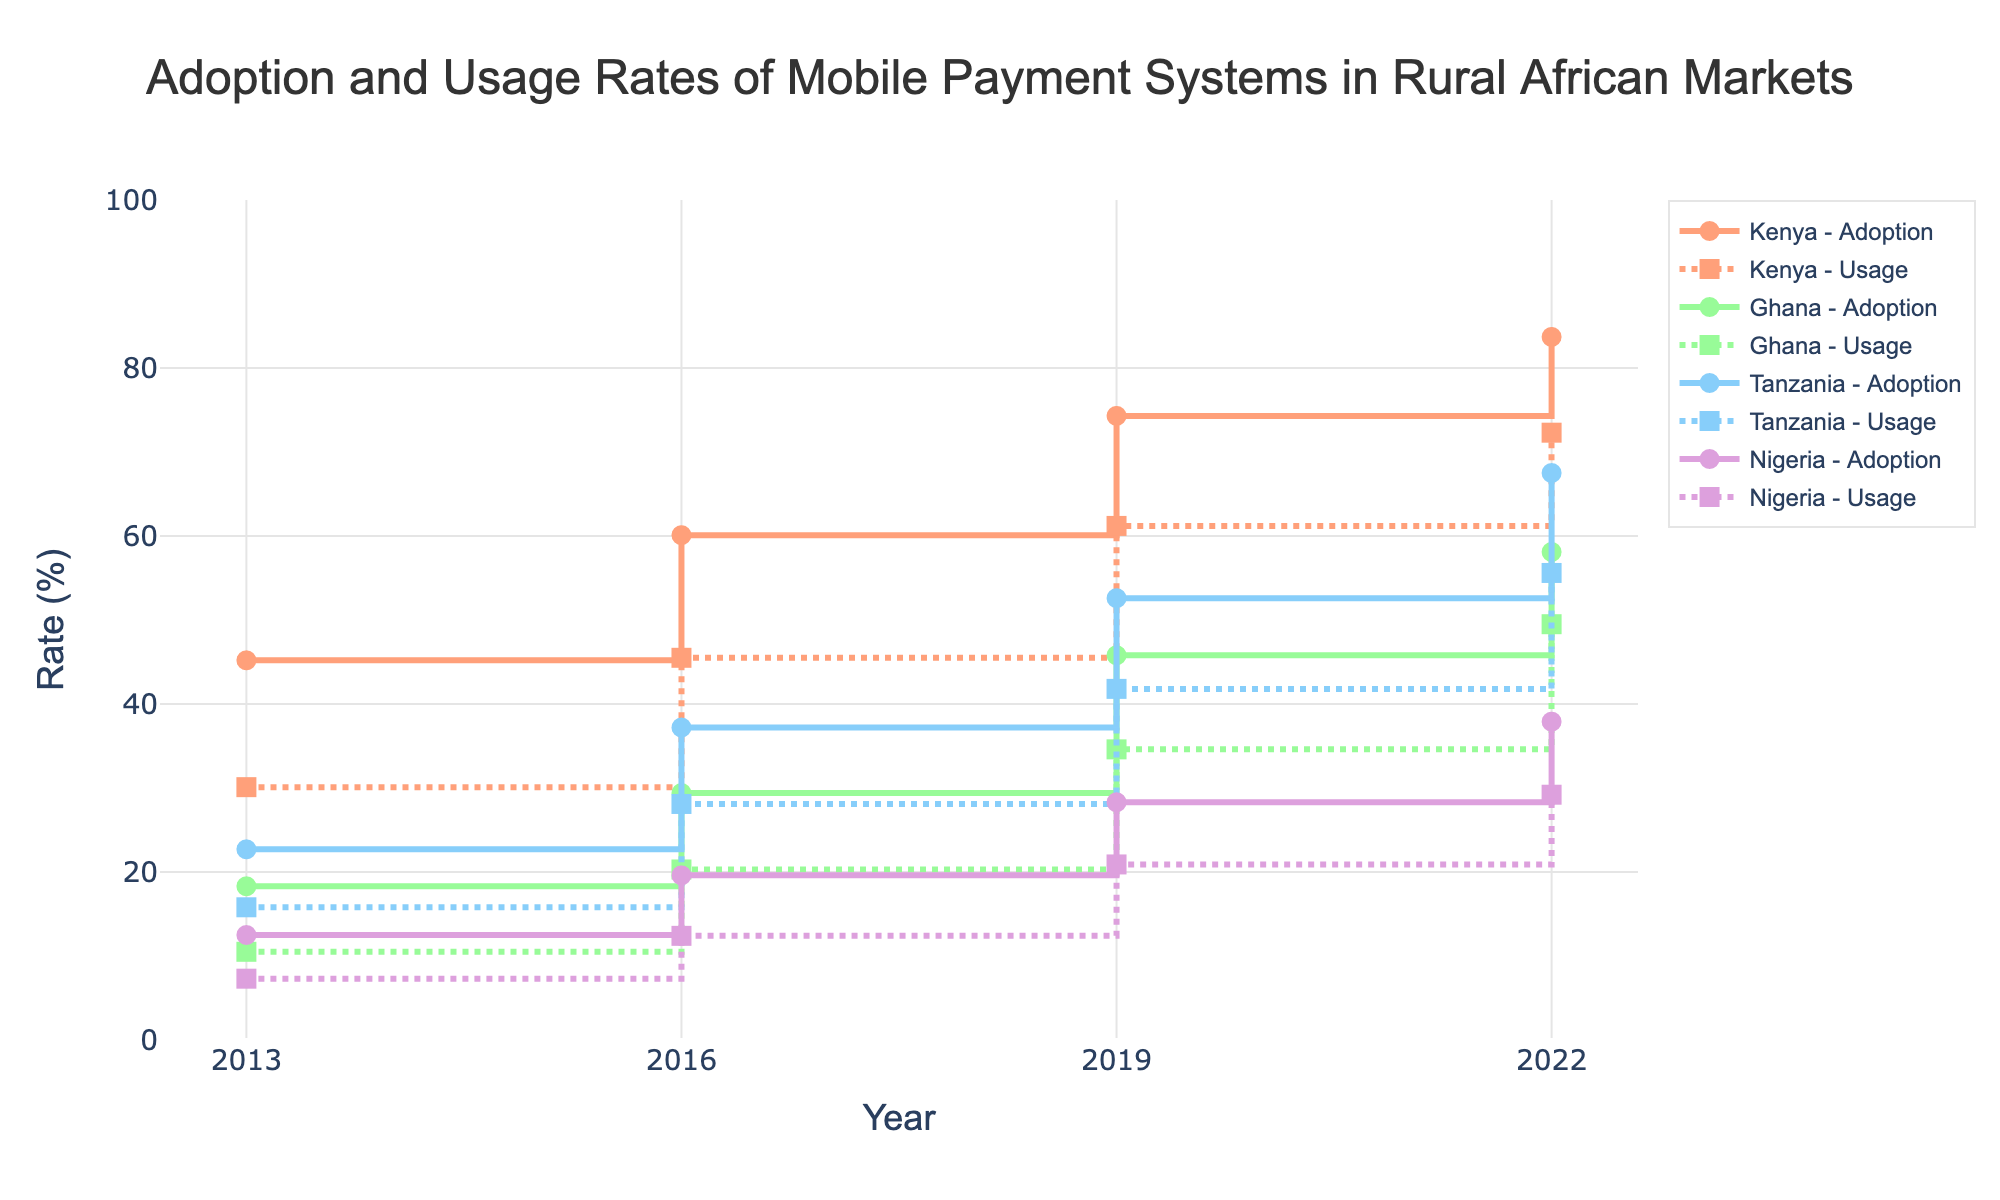what is the title of the figure? The title is always located at the top center of the figure and is usually the most prominent text. In this figure, it clearly states the content being visualized.
Answer: Adoption and Usage Rates of Mobile Payment Systems in Rural African Markets What years are covered in the figure? By examining the x-axis, which represents the years, we can see the tick marks indicating each year that data was collected.
Answer: 2013, 2016, 2019, 2022 Which country shows the highest adoption rate in 2022? By looking at the markers for the adoption rate in the year 2022 and identifying the highest point among them, we see that Kenya has the highest adoption rate.
Answer: Kenya How does the usage rate in Ghana in 2016 compare to the usage rate in Tanzania in the same year? To answer this, we locate the usage rate markers for both Ghana and Tanzania in 2016 and compare their values. Ghana's rate is 20.3%, while Tanzania's rate is 28.1%, making Tanzania's usage rate higher.
Answer: Tanzania's rate is higher What is the average adoption rate for Nigeria over the years presented in the figure? First, list Nigeria's adoption rates for all the years (12.5%, 19.6%, 28.3%, 37.9%), then sum these values and divide by the number of years to get the average. (12.5 + 19.6 + 28.3 + 37.9) / 4 = 24.575%.
Answer: 24.575% Which country shows the largest increase in adoption rate from 2013 to 2022? To find this, calculate the difference in adoption rates for each country between 2013 and 2022, then compare the differences. Kenya's increase is 83.7 - 45.2 = 38.5, Ghana's is 58.1 - 18.3 = 39.8, Tanzania's is 67.5 - 22.7 = 44.8, and Nigeria's is 37.9 - 12.5 = 25.4. Tanzania shows the largest increase.
Answer: Tanzania What was the usage rate trend for Kenya from 2013 to 2022? By examining the usage rate points for Kenya over each year presented, we see that the values increase consistently: 30.1%, 45.5%, 61.2%, 72.3%, indicating a steadily upward trend.
Answer: Increasing Which country had a lower adoption rate than usage rate in any year? Check each country's adoption and usage rates for all years to find occurrences where the adoption rate is lower than the usage rate. This situation does not occur in any year for any country as typically the adoption rate is higher than the usage rate.
Answer: None In 2019, which had a higher adoption rate: Ghana or Nigeria? Compare the markers for Ghana and Nigeria in 2019, where Ghana's adoption rate is 45.8% and Nigeria's is 28.3%.
Answer: Ghana What was the growth in usage rate for Tanzania from 2013 to 2022? Calculate the difference between the usage rate in 2022 and 2013 for Tanzania. The usage rate in 2022 is 55.6% and in 2013 it is 15.8%, thus the growth is 55.6 - 15.8 = 39.8%.
Answer: 39.8% 